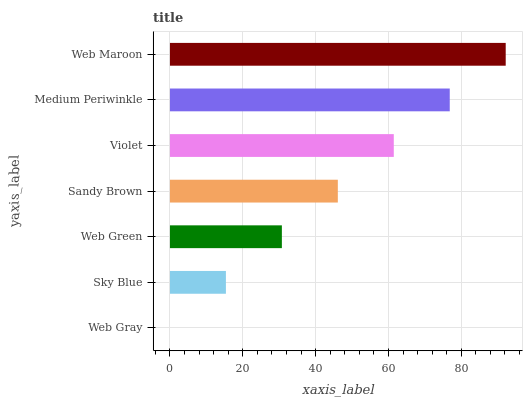Is Web Gray the minimum?
Answer yes or no. Yes. Is Web Maroon the maximum?
Answer yes or no. Yes. Is Sky Blue the minimum?
Answer yes or no. No. Is Sky Blue the maximum?
Answer yes or no. No. Is Sky Blue greater than Web Gray?
Answer yes or no. Yes. Is Web Gray less than Sky Blue?
Answer yes or no. Yes. Is Web Gray greater than Sky Blue?
Answer yes or no. No. Is Sky Blue less than Web Gray?
Answer yes or no. No. Is Sandy Brown the high median?
Answer yes or no. Yes. Is Sandy Brown the low median?
Answer yes or no. Yes. Is Web Green the high median?
Answer yes or no. No. Is Web Gray the low median?
Answer yes or no. No. 